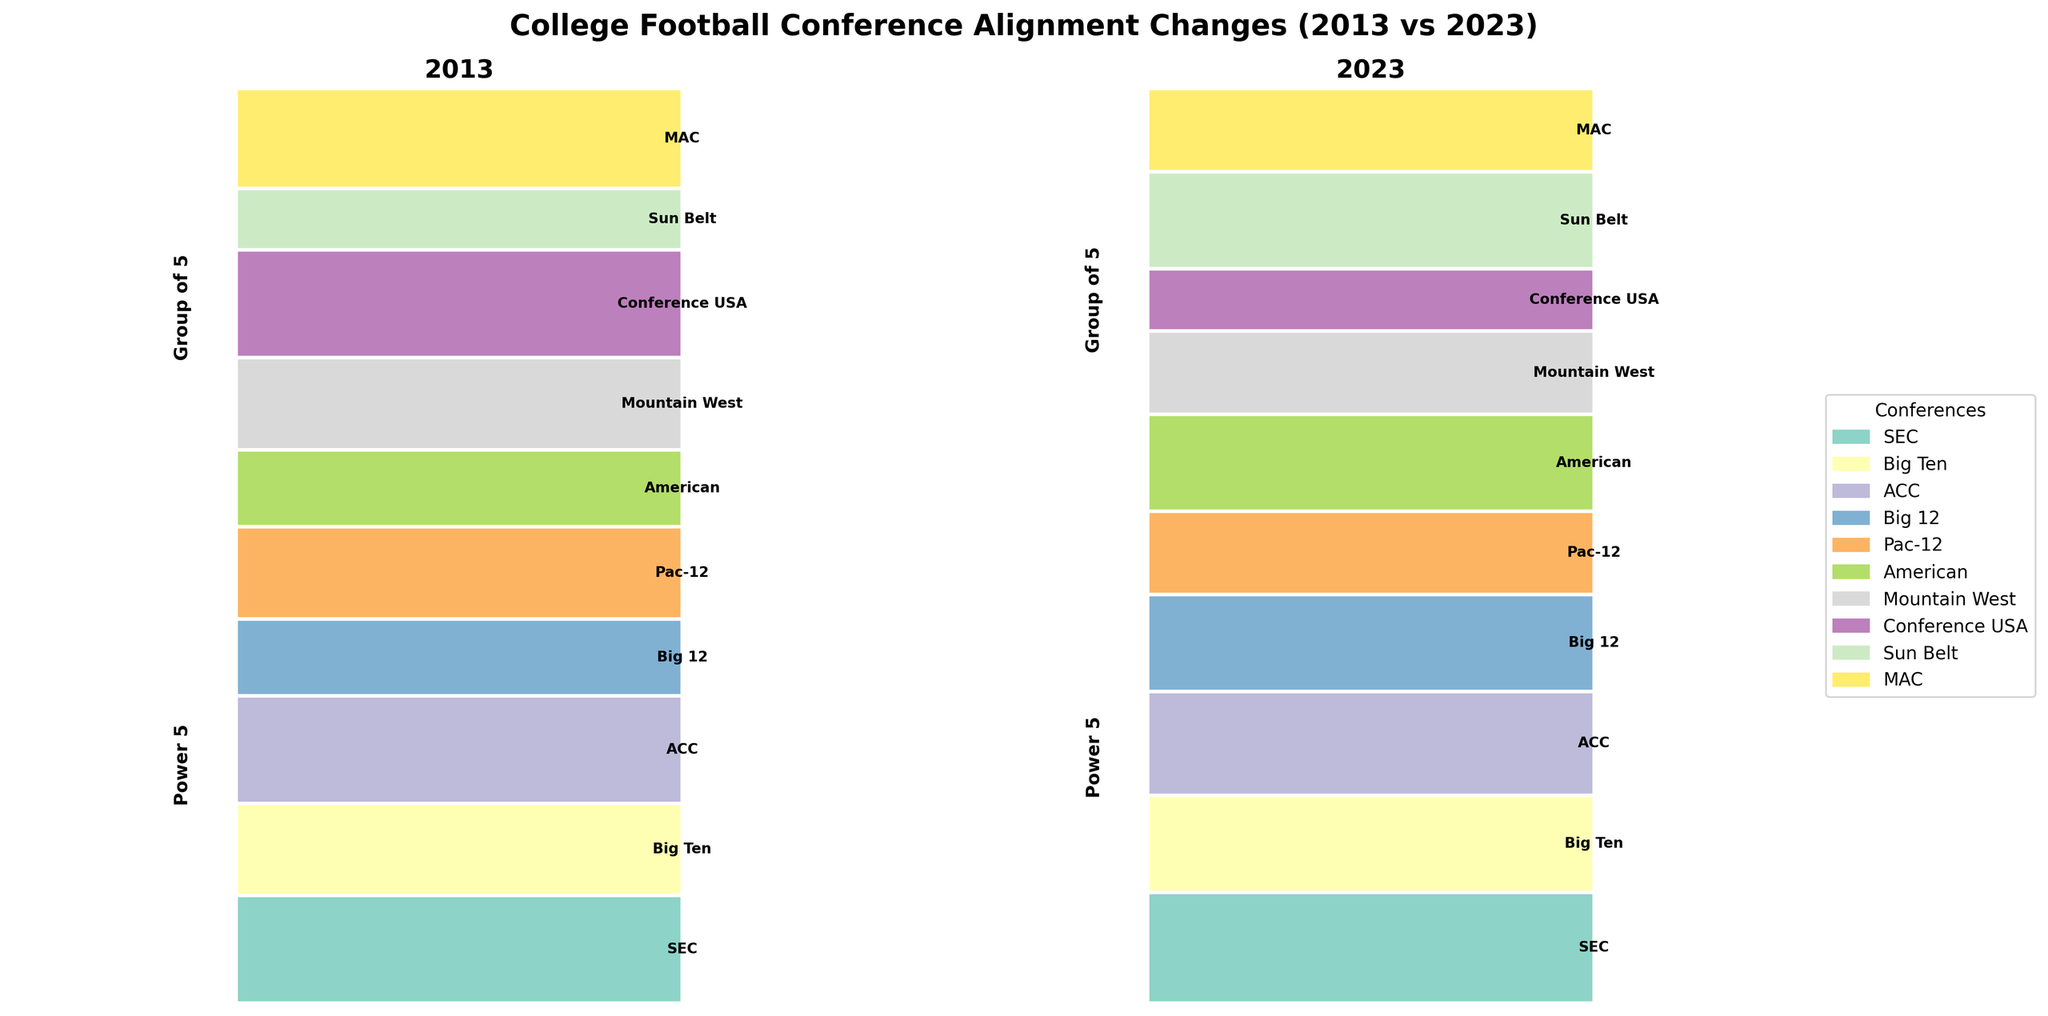What's the title of the figure? The title of the figure can be found at the top center of the visualization. It is usually larger in font and bold to indicate its importance.
Answer: College Football Conference Alignment Changes (2013 vs 2023) How many Power 5 conferences were there in 2023? The conferences categorized as Power 5 can be identified by their labels. Count the Power 5 conferences in the 2023 portion of the mosaic plot.
Answer: 5 Which Group of 5 conference saw a decrease in the number of members from 2013 to 2023? Look at the Group of 5 conferences in both the 2013 and 2023 portions of the plot and identify the one where the proportion is smaller in 2023 than in 2013.
Answer: Conference USA Which conference had an increase in the number of members in 2023 compared to 2013 among the Power 5 conferences? Review the Power 5 conferences in both parts of the plot and identify which ones have a larger proportional area in 2023 than in 2013. Multiple conferences might have increased, so we need the exact proportions.
Answer: SEC, Big Ten, ACC, Big 12 What is the combined proportion of the Sun Belt conference in 2013 and 2023? Identify the proportional heights of the Sun Belt segment in both 2013 and 2023. Sum these two proportions together to get the combined proportion. This involves reading the plot for each year and performing an addition operation.
Answer: 0.03 (2013) + 0.059 (2023) = 0.089 Which year had the highest proportion of the American Athletic Conference members? Compare the proportion of the American Athletic Conference members between 2013 and 2023 and determine which year’s segment is larger.
Answer: 2023 Compare the proportions of the Big Ten and the Pac-12 conferences in 2023. Which one has a higher proportion? Look at the mosaic plot for the year 2023 and compare the heights of the segments for the Big Ten and the Pac-12. Identify which one is taller.
Answer: Big Ten Among the Power 5 conferences, which one had the least change in the proportion of members from 2013 to 2023? Measure and compare the differences in proportions for each Power 5 conference between the two years. The one with the least difference (absolute value) is the answer.
Answer: Pac-12 In terms of alignment changes, which conference category experienced more shifts between 2013 and 2023? Compare the overall changes in proportions within the Power 5 and Group of 5 categories by assessing the combined differences in proportions for each conference in the two categories. The category with more noticeable shifts represents the answer.
Answer: Group of 5 What is the total number of members for Group of 5 conferences in 2023? Sum the number of members for each Group of 5 conference (American, Mountain West, Conference USA, Sun Belt, MAC) as given in the data for 2023.
Answer: 61 